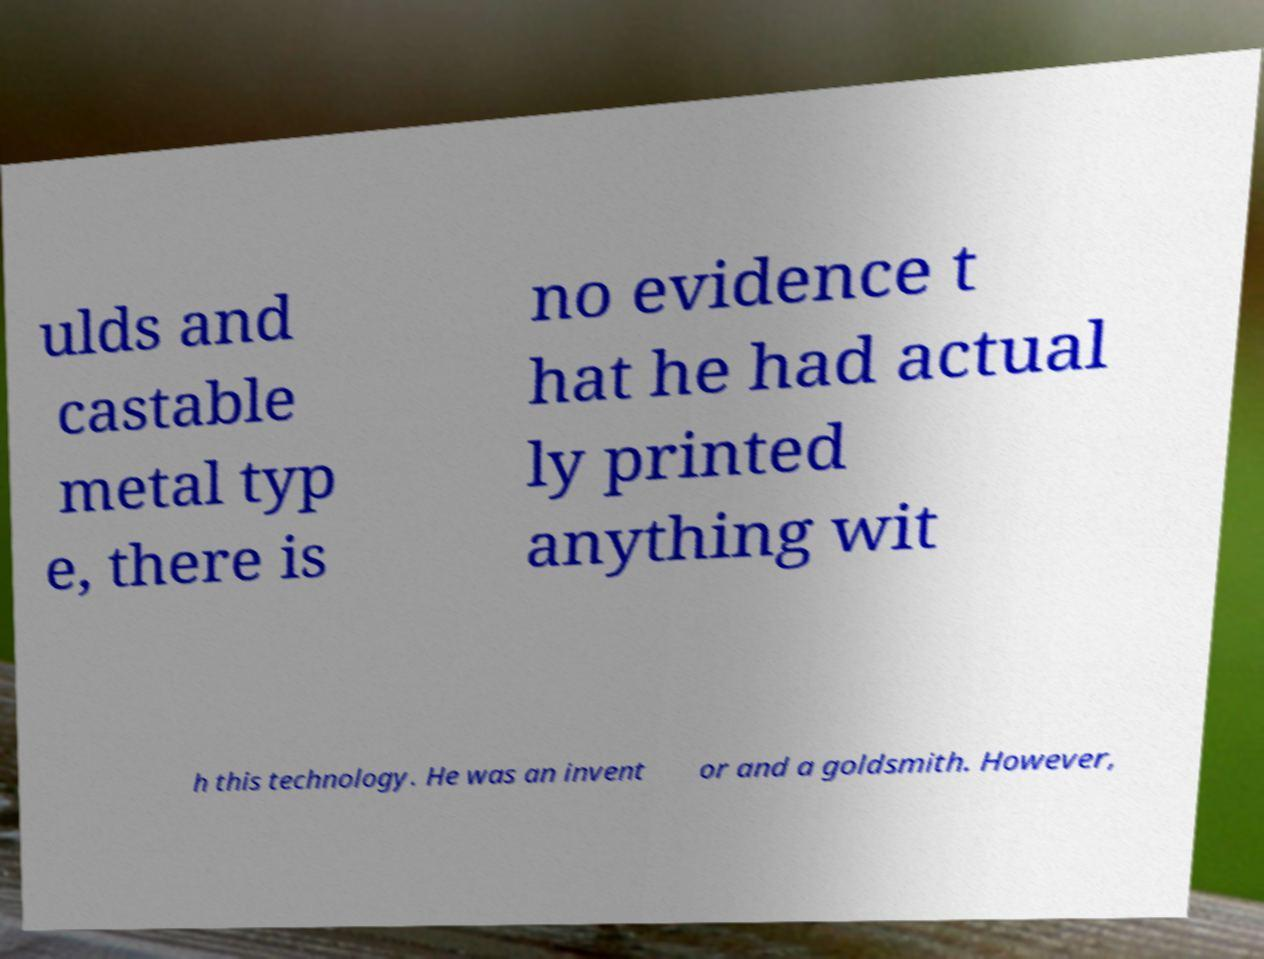What messages or text are displayed in this image? I need them in a readable, typed format. ulds and castable metal typ e, there is no evidence t hat he had actual ly printed anything wit h this technology. He was an invent or and a goldsmith. However, 